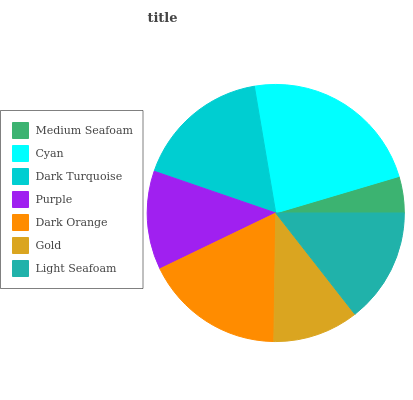Is Medium Seafoam the minimum?
Answer yes or no. Yes. Is Cyan the maximum?
Answer yes or no. Yes. Is Dark Turquoise the minimum?
Answer yes or no. No. Is Dark Turquoise the maximum?
Answer yes or no. No. Is Cyan greater than Dark Turquoise?
Answer yes or no. Yes. Is Dark Turquoise less than Cyan?
Answer yes or no. Yes. Is Dark Turquoise greater than Cyan?
Answer yes or no. No. Is Cyan less than Dark Turquoise?
Answer yes or no. No. Is Light Seafoam the high median?
Answer yes or no. Yes. Is Light Seafoam the low median?
Answer yes or no. Yes. Is Dark Turquoise the high median?
Answer yes or no. No. Is Cyan the low median?
Answer yes or no. No. 